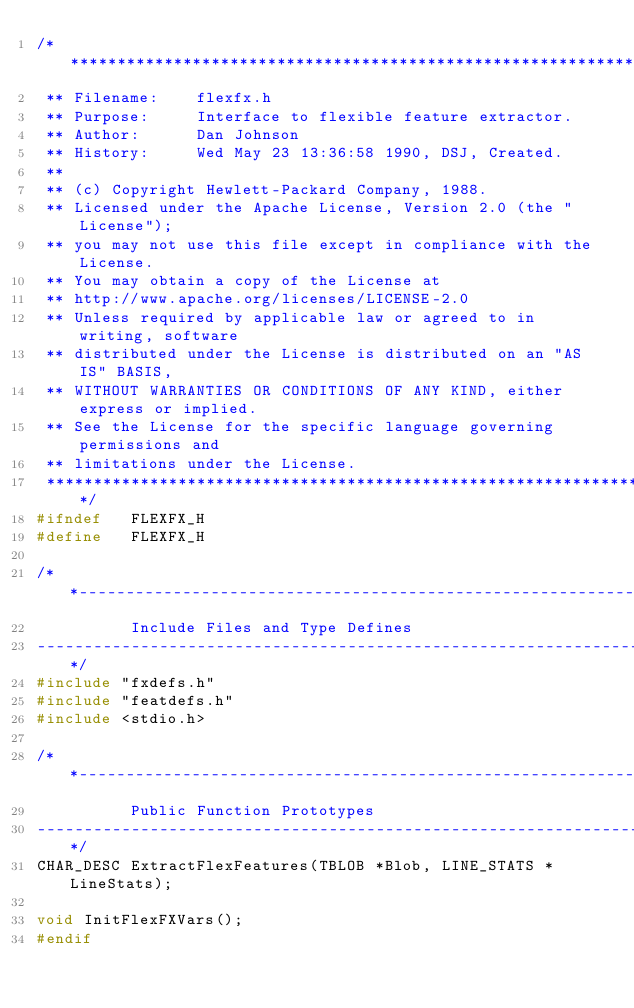<code> <loc_0><loc_0><loc_500><loc_500><_C_>/******************************************************************************
 **	Filename:    flexfx.h
 **	Purpose:     Interface to flexible feature extractor.
 **	Author:      Dan Johnson
 **	History:     Wed May 23 13:36:58 1990, DSJ, Created.
 **
 **	(c) Copyright Hewlett-Packard Company, 1988.
 ** Licensed under the Apache License, Version 2.0 (the "License");
 ** you may not use this file except in compliance with the License.
 ** You may obtain a copy of the License at
 ** http://www.apache.org/licenses/LICENSE-2.0
 ** Unless required by applicable law or agreed to in writing, software
 ** distributed under the License is distributed on an "AS IS" BASIS,
 ** WITHOUT WARRANTIES OR CONDITIONS OF ANY KIND, either express or implied.
 ** See the License for the specific language governing permissions and
 ** limitations under the License.
 ******************************************************************************/
#ifndef   FLEXFX_H
#define   FLEXFX_H

/**----------------------------------------------------------------------------
          Include Files and Type Defines
----------------------------------------------------------------------------**/
#include "fxdefs.h"
#include "featdefs.h"
#include <stdio.h>

/**----------------------------------------------------------------------------
          Public Function Prototypes
----------------------------------------------------------------------------**/
CHAR_DESC ExtractFlexFeatures(TBLOB *Blob, LINE_STATS *LineStats); 

void InitFlexFXVars(); 
#endif
</code> 